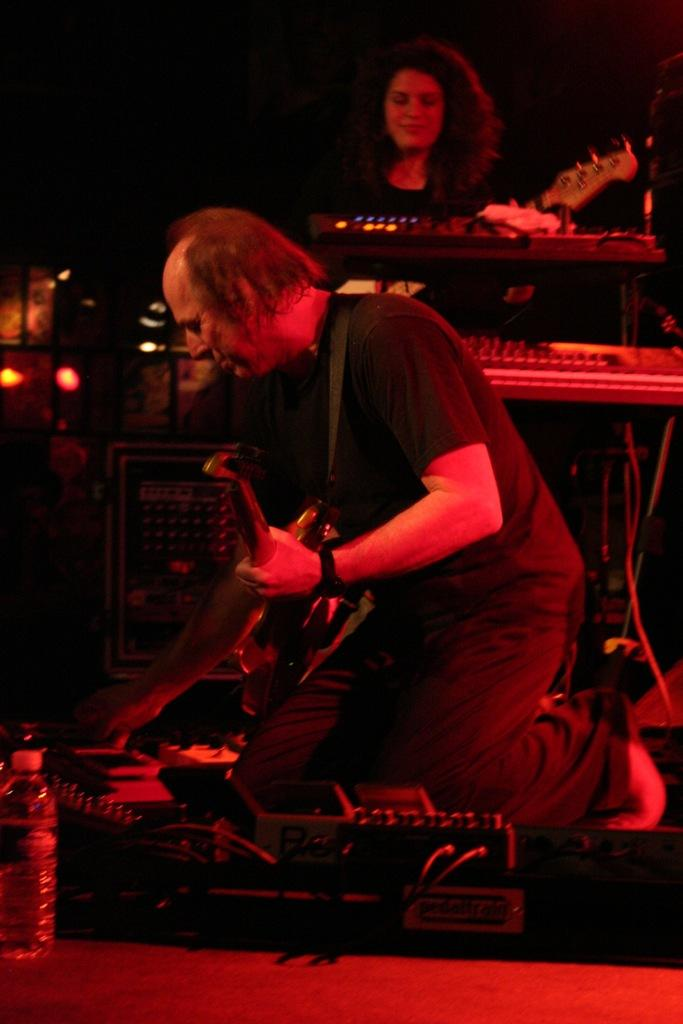What are the people in the image doing? The people in the image are playing musical instruments. Can you describe any other objects in the image besides the musical instruments? Yes, there is a bottle on a surface in the image. Are the people in the image protesting against something? There is no indication in the image that the people are protesting against anything. Can you see any yaks in the image? There are no yaks present in the image. 